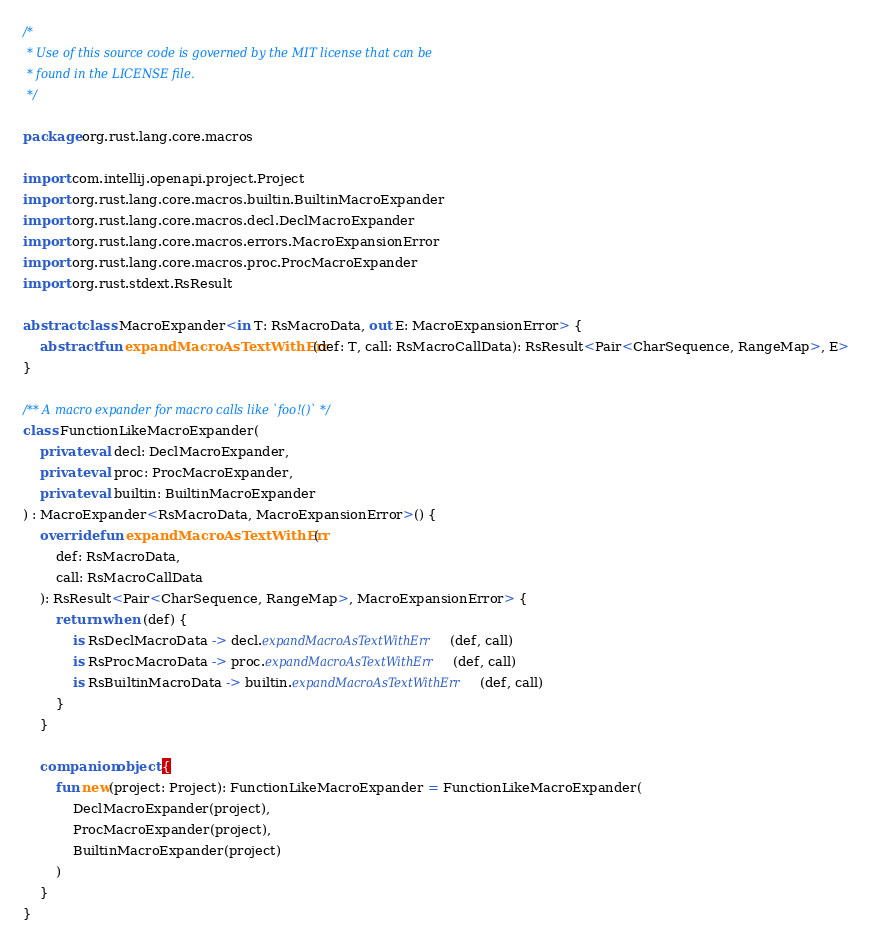Convert code to text. <code><loc_0><loc_0><loc_500><loc_500><_Kotlin_>/*
 * Use of this source code is governed by the MIT license that can be
 * found in the LICENSE file.
 */

package org.rust.lang.core.macros

import com.intellij.openapi.project.Project
import org.rust.lang.core.macros.builtin.BuiltinMacroExpander
import org.rust.lang.core.macros.decl.DeclMacroExpander
import org.rust.lang.core.macros.errors.MacroExpansionError
import org.rust.lang.core.macros.proc.ProcMacroExpander
import org.rust.stdext.RsResult

abstract class MacroExpander<in T: RsMacroData, out E: MacroExpansionError> {
    abstract fun expandMacroAsTextWithErr(def: T, call: RsMacroCallData): RsResult<Pair<CharSequence, RangeMap>, E>
}

/** A macro expander for macro calls like `foo!()` */
class FunctionLikeMacroExpander(
    private val decl: DeclMacroExpander,
    private val proc: ProcMacroExpander,
    private val builtin: BuiltinMacroExpander
) : MacroExpander<RsMacroData, MacroExpansionError>() {
    override fun expandMacroAsTextWithErr(
        def: RsMacroData,
        call: RsMacroCallData
    ): RsResult<Pair<CharSequence, RangeMap>, MacroExpansionError> {
        return when (def) {
            is RsDeclMacroData -> decl.expandMacroAsTextWithErr(def, call)
            is RsProcMacroData -> proc.expandMacroAsTextWithErr(def, call)
            is RsBuiltinMacroData -> builtin.expandMacroAsTextWithErr(def, call)
        }
    }

    companion object {
        fun new(project: Project): FunctionLikeMacroExpander = FunctionLikeMacroExpander(
            DeclMacroExpander(project),
            ProcMacroExpander(project),
            BuiltinMacroExpander(project)
        )
    }
}
</code> 